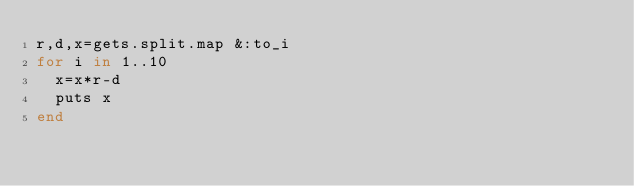Convert code to text. <code><loc_0><loc_0><loc_500><loc_500><_Ruby_>r,d,x=gets.split.map &:to_i
for i in 1..10
  x=x*r-d
  puts x
end
</code> 